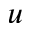Convert formula to latex. <formula><loc_0><loc_0><loc_500><loc_500>u</formula> 